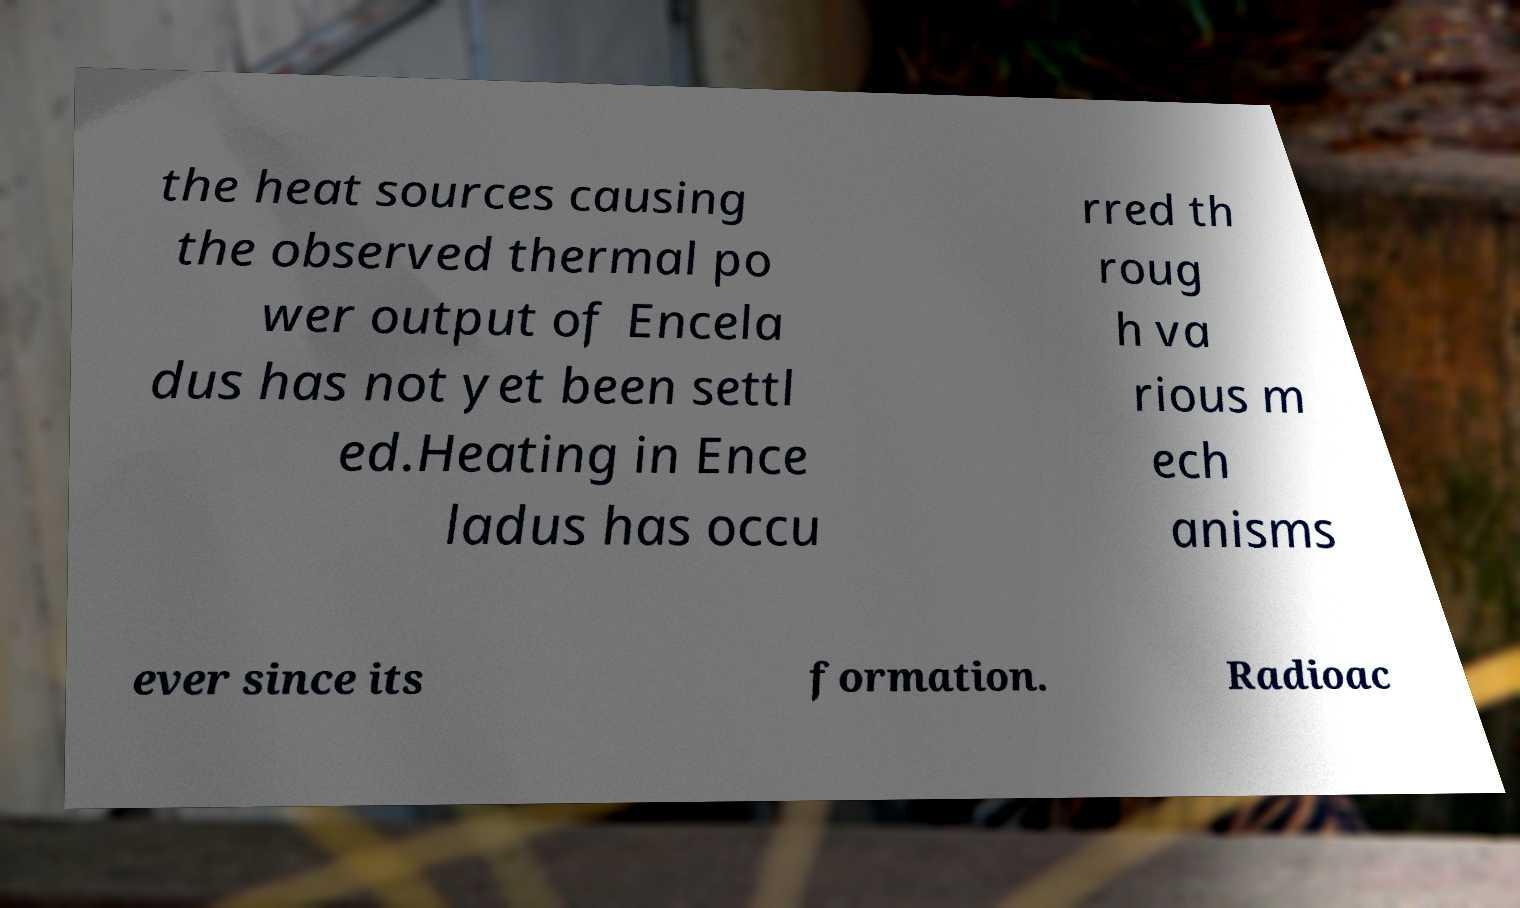Please identify and transcribe the text found in this image. the heat sources causing the observed thermal po wer output of Encela dus has not yet been settl ed.Heating in Ence ladus has occu rred th roug h va rious m ech anisms ever since its formation. Radioac 